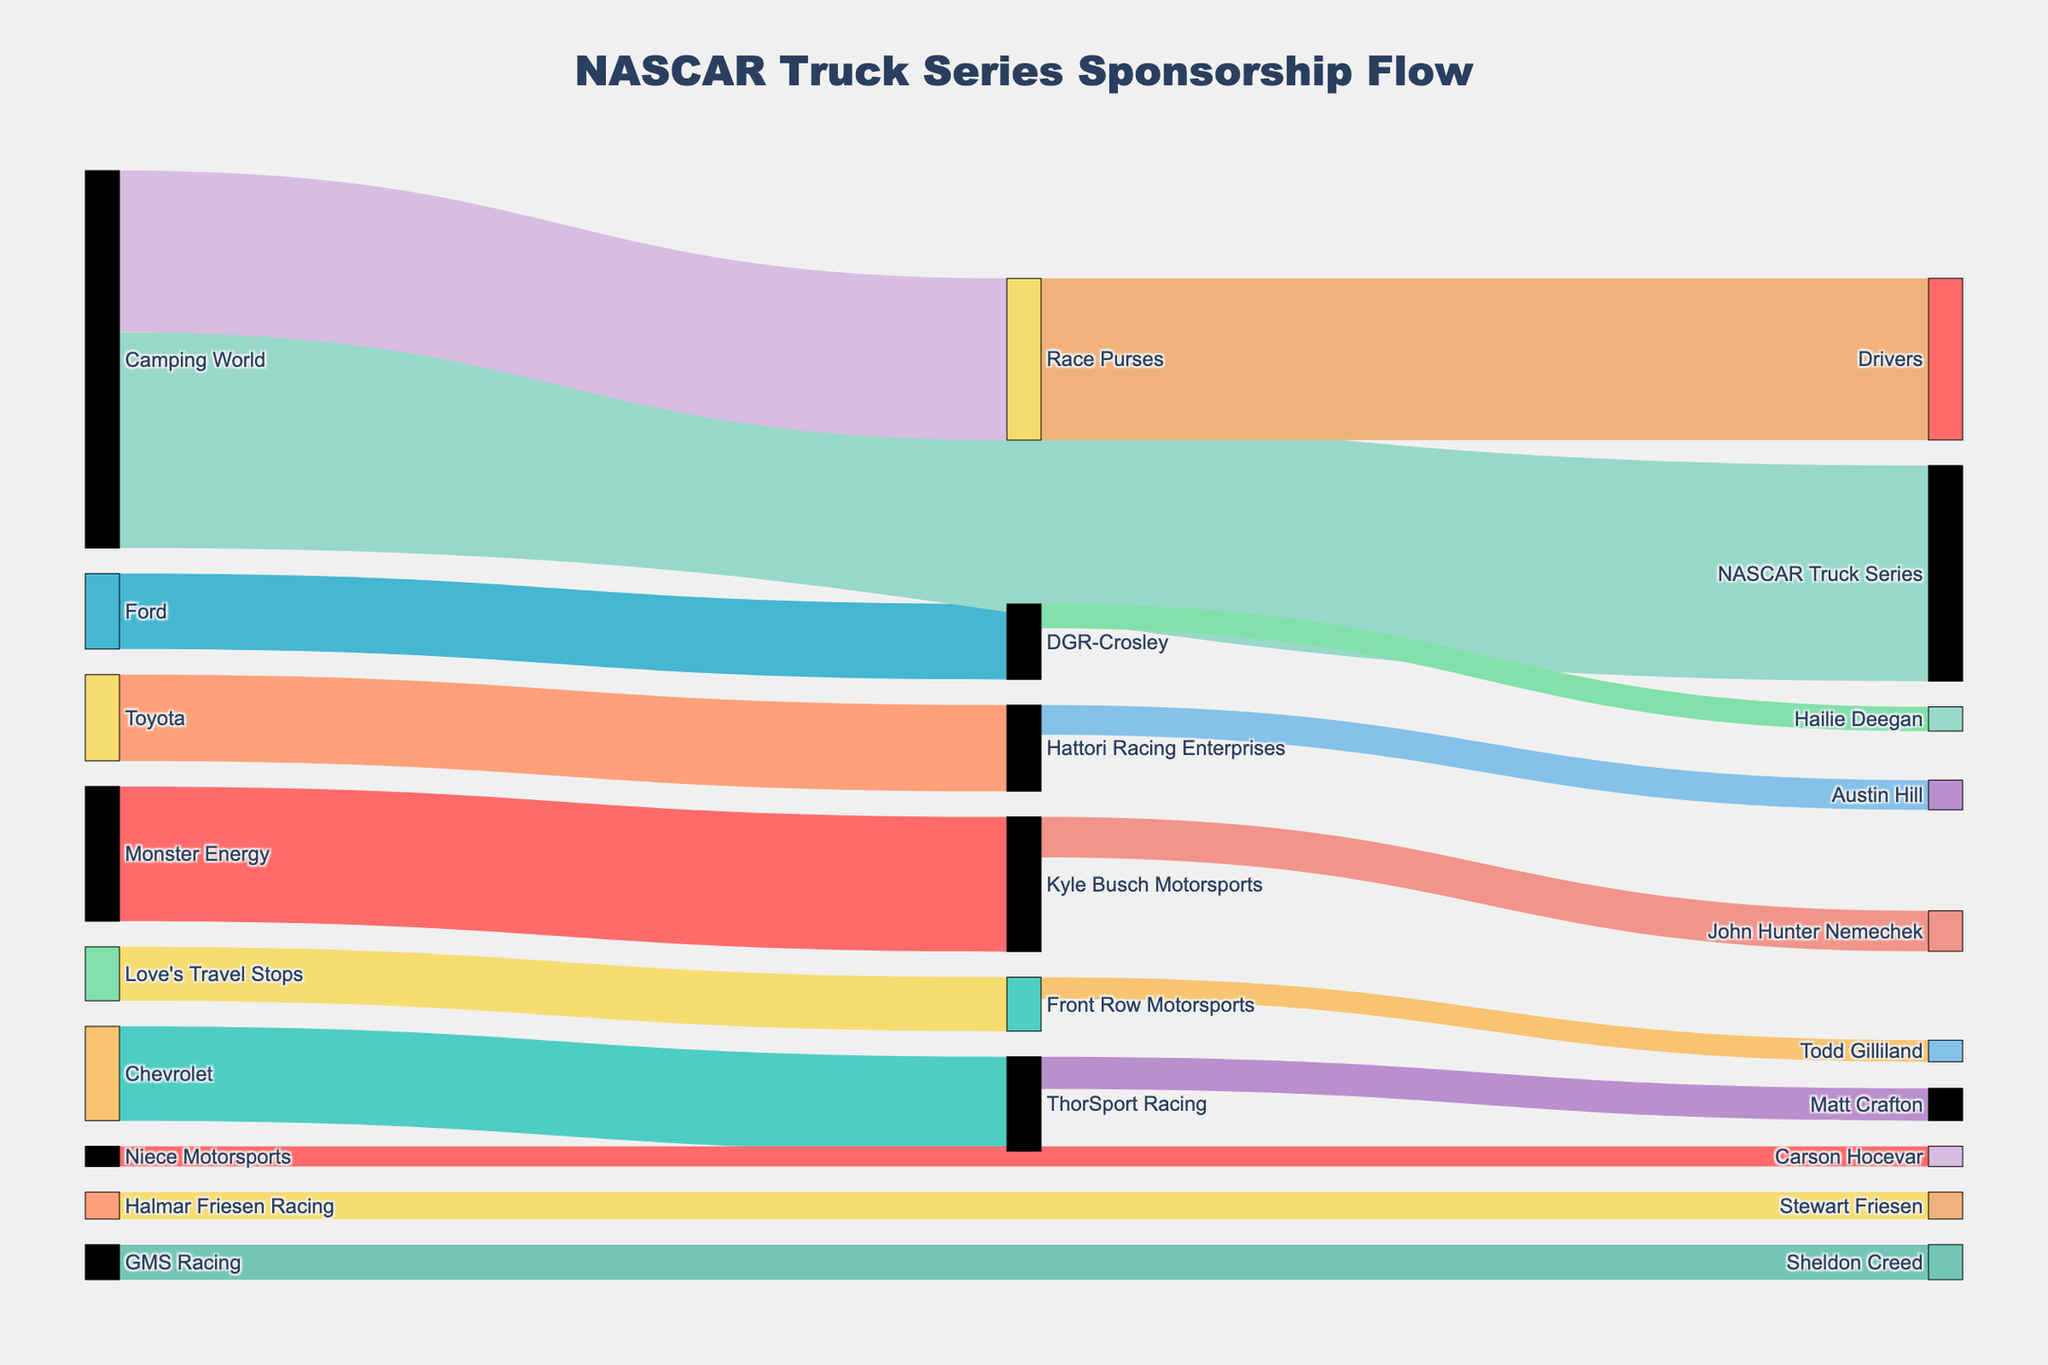How many sponsors provide funding in the NASCAR Truck Series? Count the unique labels in the source nodes that represent sponsors. In this diagram, sponsors are Monster Energy, Chevrolet, Ford, Toyota, Camping World, and Love's Travel Stops.
Answer: 6 Which sponsor provides the highest amount of funding, and how much is it? Identify the source node with the highest value. Camping World provides $8,000,000.
Answer: Camping World, $8,000,000 What is the total funding received by Kyle Busch Motorsports? Sum the values from all links where the target is Kyle Busch Motorsports. This includes $5,000,000 from Monster Energy.
Answer: $5,000,000 Compare the funding received by John Hunter Nemechek and Matt Crafton. Who gets more, and by how much? Identify the target nodes for John Hunter Nemechek and Matt Crafton and find their values. John Hunter Nemechek receives $1,500,000, and Matt Crafton gets $1,200,000. The difference is $300,000 more for John Hunter Nemechek.
Answer: John Hunter Nemechek by $300,000 How much total funding flows from Toyota? Sum the values from all links where the source is Toyota. This includes $3,200,000 to Hattori Racing Enterprises.
Answer: $3,200,000 How does the funding from Monster Energy split among the teams? Identify the links originating from Monster Energy. It flows $5,000,000 to Kyle Busch Motorsports.
Answer: $5,000,000 to Kyle Busch Motorsports Which team receives funding from Love’s Travel Stops, and how much is it? Look at the link where the source is Love’s Travel Stops. It goes to Front Row Motorsports with a value of $2,000,000.
Answer: Front Row Motorsports, $2,000,000 What is the total prize money distributed among the drivers? Find the link where the target is Drivers. $6,000,000 is distributed from Race Purses to Drivers.
Answer: $6,000,000 